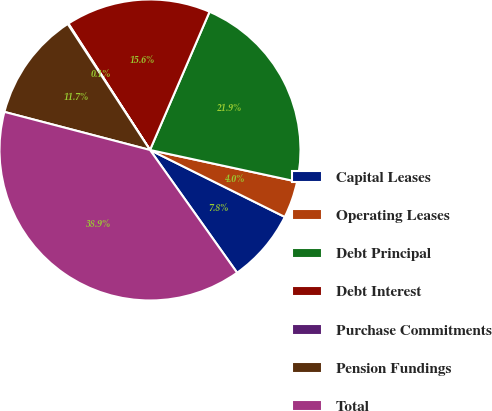<chart> <loc_0><loc_0><loc_500><loc_500><pie_chart><fcel>Capital Leases<fcel>Operating Leases<fcel>Debt Principal<fcel>Debt Interest<fcel>Purchase Commitments<fcel>Pension Fundings<fcel>Total<nl><fcel>7.84%<fcel>3.96%<fcel>21.9%<fcel>15.6%<fcel>0.08%<fcel>11.72%<fcel>38.89%<nl></chart> 